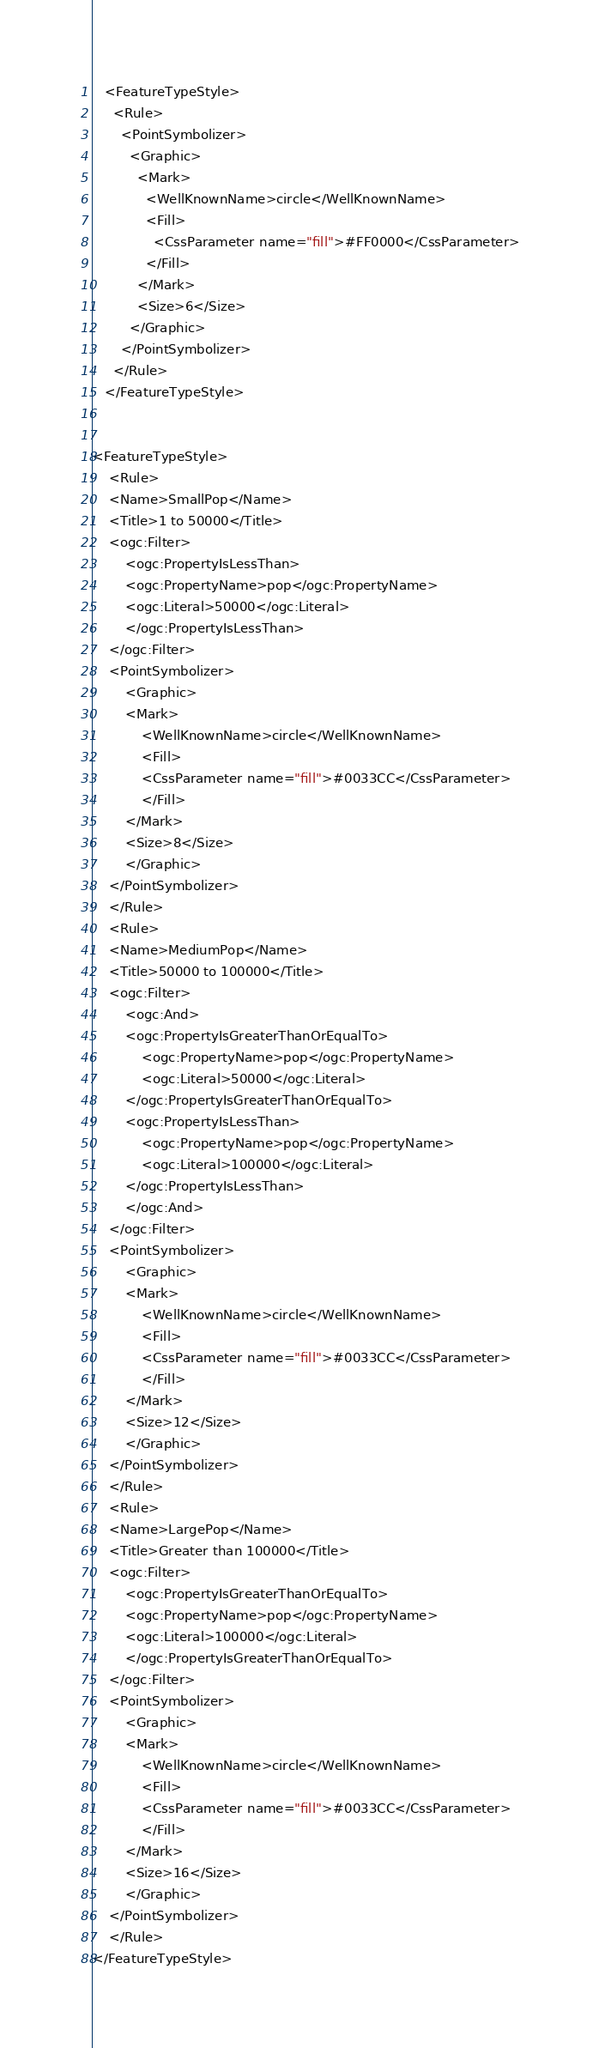<code> <loc_0><loc_0><loc_500><loc_500><_Scheme_>   <FeatureTypeStyle>
     <Rule>
       <PointSymbolizer>
         <Graphic>
           <Mark>
             <WellKnownName>circle</WellKnownName>
             <Fill>
               <CssParameter name="fill">#FF0000</CssParameter>
             </Fill>
           </Mark>
           <Size>6</Size>
         </Graphic>
       </PointSymbolizer>
     </Rule>
   </FeatureTypeStyle>


<FeatureTypeStyle>
    <Rule>
    <Name>SmallPop</Name>
    <Title>1 to 50000</Title>
    <ogc:Filter>
        <ogc:PropertyIsLessThan>
        <ogc:PropertyName>pop</ogc:PropertyName>
        <ogc:Literal>50000</ogc:Literal>
        </ogc:PropertyIsLessThan>
    </ogc:Filter>
    <PointSymbolizer>
        <Graphic>
        <Mark>
            <WellKnownName>circle</WellKnownName>
            <Fill>
            <CssParameter name="fill">#0033CC</CssParameter>
            </Fill>
        </Mark>
        <Size>8</Size>
        </Graphic>
    </PointSymbolizer>
    </Rule>
    <Rule>
    <Name>MediumPop</Name>
    <Title>50000 to 100000</Title>
    <ogc:Filter>
        <ogc:And>
        <ogc:PropertyIsGreaterThanOrEqualTo>
            <ogc:PropertyName>pop</ogc:PropertyName>
            <ogc:Literal>50000</ogc:Literal>
        </ogc:PropertyIsGreaterThanOrEqualTo>
        <ogc:PropertyIsLessThan>
            <ogc:PropertyName>pop</ogc:PropertyName>
            <ogc:Literal>100000</ogc:Literal>
        </ogc:PropertyIsLessThan>
        </ogc:And>
    </ogc:Filter>
    <PointSymbolizer>
        <Graphic>
        <Mark>
            <WellKnownName>circle</WellKnownName>
            <Fill>
            <CssParameter name="fill">#0033CC</CssParameter>
            </Fill>
        </Mark>
        <Size>12</Size>
        </Graphic>
    </PointSymbolizer>
    </Rule>
    <Rule>
    <Name>LargePop</Name>
    <Title>Greater than 100000</Title>
    <ogc:Filter>
        <ogc:PropertyIsGreaterThanOrEqualTo>
        <ogc:PropertyName>pop</ogc:PropertyName>
        <ogc:Literal>100000</ogc:Literal>
        </ogc:PropertyIsGreaterThanOrEqualTo>
    </ogc:Filter>
    <PointSymbolizer>
        <Graphic>
        <Mark>
            <WellKnownName>circle</WellKnownName>
            <Fill>
            <CssParameter name="fill">#0033CC</CssParameter>
            </Fill>
        </Mark>
        <Size>16</Size>
        </Graphic>
    </PointSymbolizer>
    </Rule>
</FeatureTypeStyle></code> 